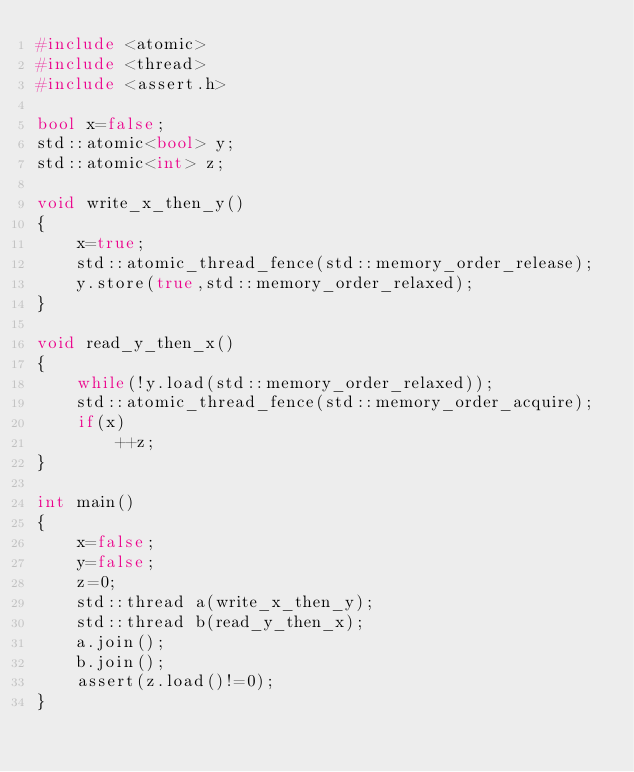Convert code to text. <code><loc_0><loc_0><loc_500><loc_500><_C++_>#include <atomic>
#include <thread>
#include <assert.h>

bool x=false;
std::atomic<bool> y;
std::atomic<int> z;

void write_x_then_y()
{
    x=true;
    std::atomic_thread_fence(std::memory_order_release);
    y.store(true,std::memory_order_relaxed);
}

void read_y_then_x()
{
    while(!y.load(std::memory_order_relaxed));
    std::atomic_thread_fence(std::memory_order_acquire);
    if(x)
        ++z;
}

int main()
{
    x=false;
    y=false;
    z=0;
    std::thread a(write_x_then_y);
    std::thread b(read_y_then_x);
    a.join();
    b.join();
    assert(z.load()!=0);
}
</code> 